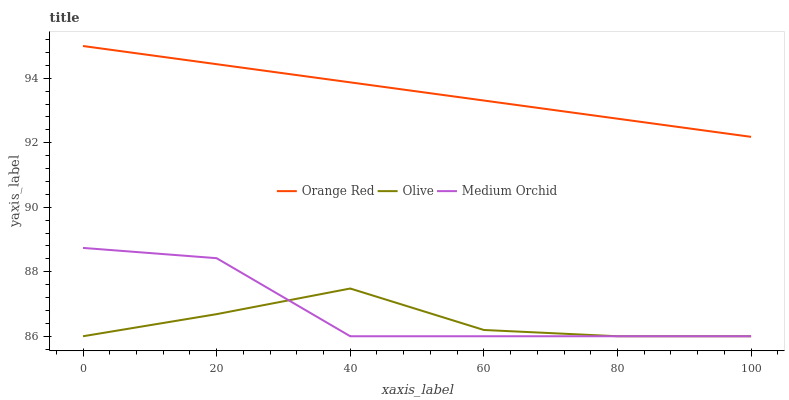Does Medium Orchid have the minimum area under the curve?
Answer yes or no. No. Does Medium Orchid have the maximum area under the curve?
Answer yes or no. No. Is Medium Orchid the smoothest?
Answer yes or no. No. Is Orange Red the roughest?
Answer yes or no. No. Does Orange Red have the lowest value?
Answer yes or no. No. Does Medium Orchid have the highest value?
Answer yes or no. No. Is Olive less than Orange Red?
Answer yes or no. Yes. Is Orange Red greater than Medium Orchid?
Answer yes or no. Yes. Does Olive intersect Orange Red?
Answer yes or no. No. 